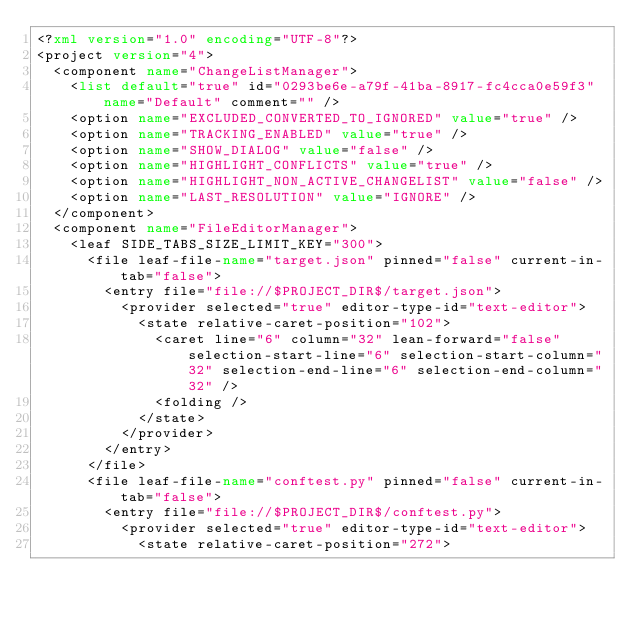<code> <loc_0><loc_0><loc_500><loc_500><_XML_><?xml version="1.0" encoding="UTF-8"?>
<project version="4">
  <component name="ChangeListManager">
    <list default="true" id="0293be6e-a79f-41ba-8917-fc4cca0e59f3" name="Default" comment="" />
    <option name="EXCLUDED_CONVERTED_TO_IGNORED" value="true" />
    <option name="TRACKING_ENABLED" value="true" />
    <option name="SHOW_DIALOG" value="false" />
    <option name="HIGHLIGHT_CONFLICTS" value="true" />
    <option name="HIGHLIGHT_NON_ACTIVE_CHANGELIST" value="false" />
    <option name="LAST_RESOLUTION" value="IGNORE" />
  </component>
  <component name="FileEditorManager">
    <leaf SIDE_TABS_SIZE_LIMIT_KEY="300">
      <file leaf-file-name="target.json" pinned="false" current-in-tab="false">
        <entry file="file://$PROJECT_DIR$/target.json">
          <provider selected="true" editor-type-id="text-editor">
            <state relative-caret-position="102">
              <caret line="6" column="32" lean-forward="false" selection-start-line="6" selection-start-column="32" selection-end-line="6" selection-end-column="32" />
              <folding />
            </state>
          </provider>
        </entry>
      </file>
      <file leaf-file-name="conftest.py" pinned="false" current-in-tab="false">
        <entry file="file://$PROJECT_DIR$/conftest.py">
          <provider selected="true" editor-type-id="text-editor">
            <state relative-caret-position="272"></code> 